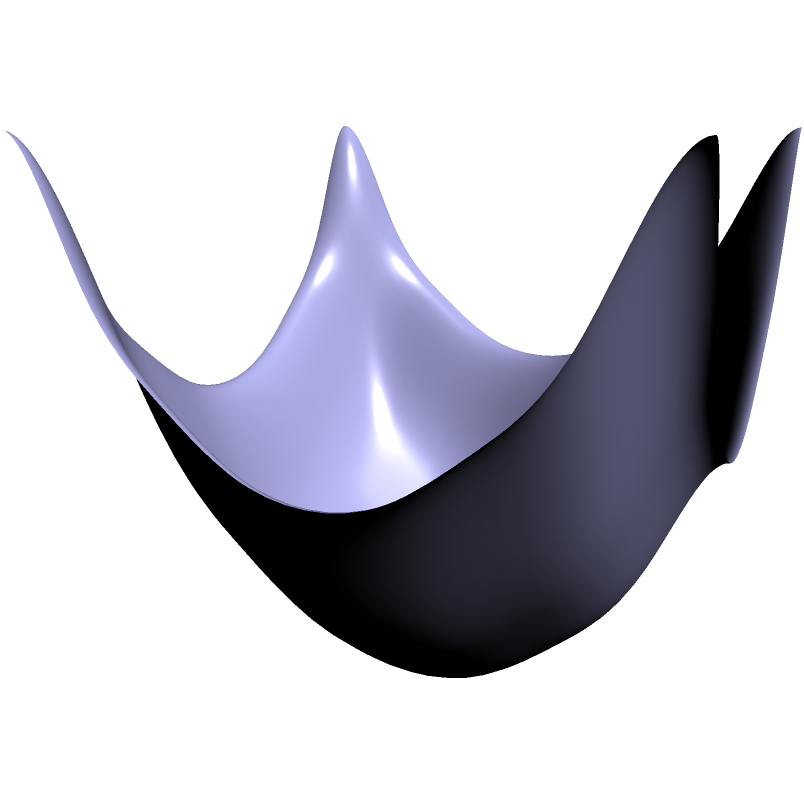As a concerned parent trying to find the most efficient route for your child's school bus, you encounter a problem involving the shortest path between two points on a curved surface. The surface is represented by the equation $z = 0.5(x^2 + y^2)$, and you need to find the shortest path from point A (0,0,0) to point B (1,1,1). Which path would you choose and why?

a) The straight line between A and B (blue line)
b) The curved path along the surface (green curve)
c) A zigzag path avoiding the steepest parts of the surface To find the shortest path between two points on a curved surface, we need to consider the following steps:

1. Understand the surface: The equation $z = 0.5(x^2 + y^2)$ represents a paraboloid, which is curved upward.

2. Identify the given points:
   Point A: (0,0,0)
   Point B: (1,1,1)

3. Consider the possible paths:
   a) Straight line (blue): This is the shortest path in 3D space but doesn't follow the surface.
   b) Curved path (green): This follows the surface of the paraboloid.
   c) Zigzag path: This would be longer than the curved path along the surface.

4. Apply the principle of geodesics: The shortest path between two points on a curved surface is called a geodesic. In this case, it's the curved path along the surface (green curve).

5. Understand why the curved path is shorter:
   - The straight line (blue) doesn't follow the surface, so it's not a valid path.
   - The zigzag path would be longer than the smooth curve along the surface.
   - The curved path (green) follows the natural contour of the surface, minimizing the distance traveled while staying on the surface.

6. Relate to real-world scenarios: In the context of a school bus route, this curved path would represent the most efficient route considering the actual landscape (hills, valleys) rather than assuming a flat surface.

Therefore, the shortest and most efficient path is the curved path along the surface (option b).
Answer: b) The curved path along the surface (green curve) 